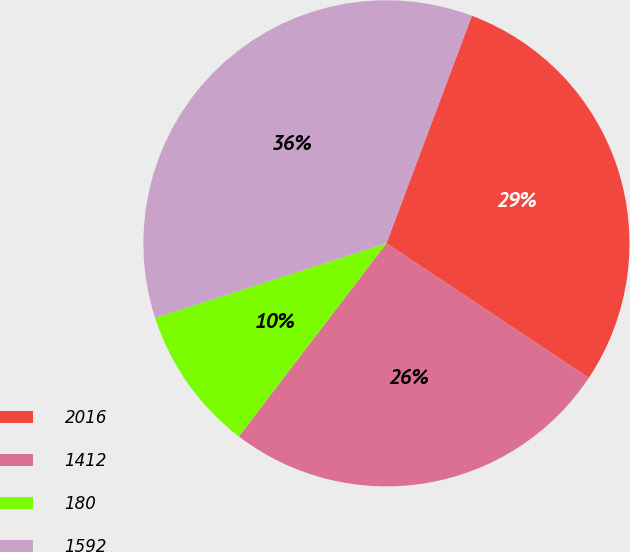Convert chart to OTSL. <chart><loc_0><loc_0><loc_500><loc_500><pie_chart><fcel>2016<fcel>1412<fcel>180<fcel>1592<nl><fcel>28.63%<fcel>26.03%<fcel>9.65%<fcel>35.68%<nl></chart> 